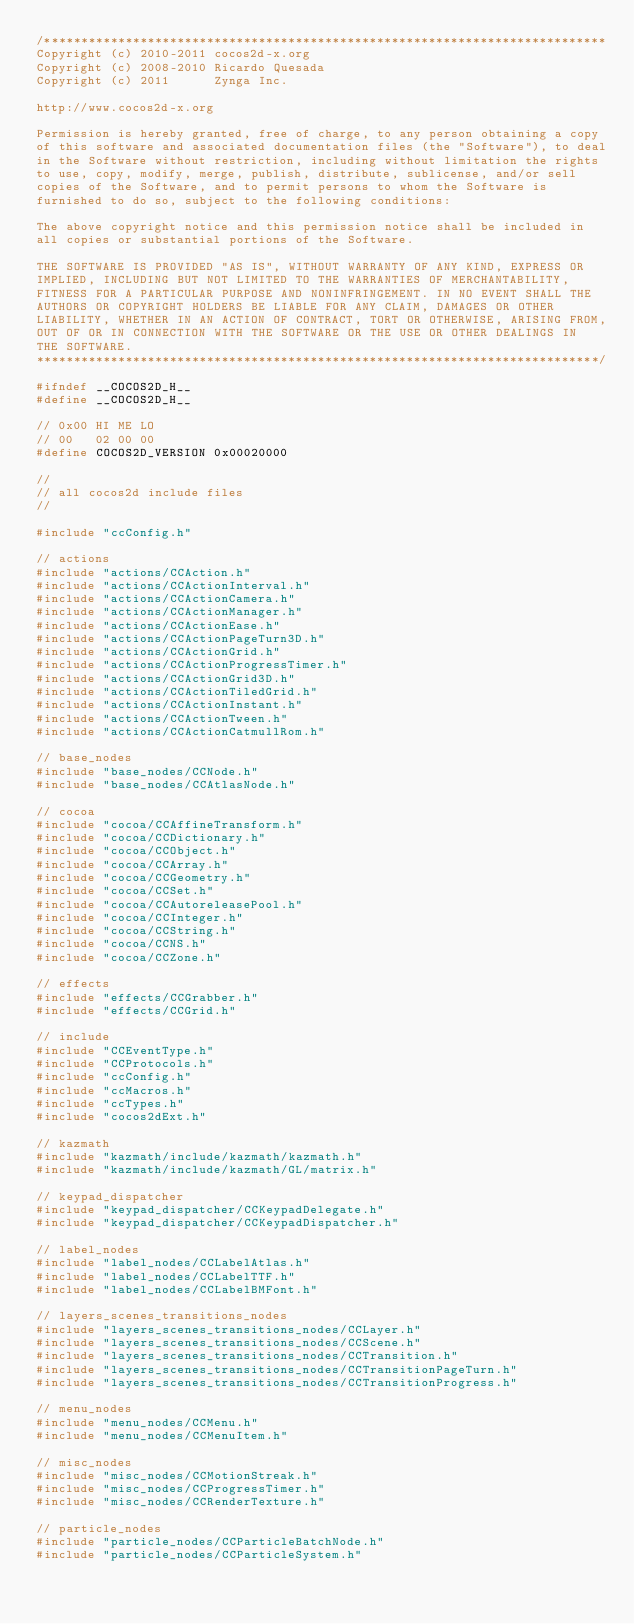<code> <loc_0><loc_0><loc_500><loc_500><_C_>/****************************************************************************
Copyright (c) 2010-2011 cocos2d-x.org
Copyright (c) 2008-2010 Ricardo Quesada
Copyright (c) 2011      Zynga Inc.

http://www.cocos2d-x.org

Permission is hereby granted, free of charge, to any person obtaining a copy
of this software and associated documentation files (the "Software"), to deal
in the Software without restriction, including without limitation the rights
to use, copy, modify, merge, publish, distribute, sublicense, and/or sell
copies of the Software, and to permit persons to whom the Software is
furnished to do so, subject to the following conditions:

The above copyright notice and this permission notice shall be included in
all copies or substantial portions of the Software.

THE SOFTWARE IS PROVIDED "AS IS", WITHOUT WARRANTY OF ANY KIND, EXPRESS OR
IMPLIED, INCLUDING BUT NOT LIMITED TO THE WARRANTIES OF MERCHANTABILITY,
FITNESS FOR A PARTICULAR PURPOSE AND NONINFRINGEMENT. IN NO EVENT SHALL THE
AUTHORS OR COPYRIGHT HOLDERS BE LIABLE FOR ANY CLAIM, DAMAGES OR OTHER
LIABILITY, WHETHER IN AN ACTION OF CONTRACT, TORT OR OTHERWISE, ARISING FROM,
OUT OF OR IN CONNECTION WITH THE SOFTWARE OR THE USE OR OTHER DEALINGS IN
THE SOFTWARE.
****************************************************************************/

#ifndef __COCOS2D_H__
#define __COCOS2D_H__

// 0x00 HI ME LO
// 00   02 00 00
#define COCOS2D_VERSION 0x00020000

//
// all cocos2d include files
//

#include "ccConfig.h"

// actions
#include "actions/CCAction.h"
#include "actions/CCActionInterval.h"
#include "actions/CCActionCamera.h"
#include "actions/CCActionManager.h"
#include "actions/CCActionEase.h"
#include "actions/CCActionPageTurn3D.h"
#include "actions/CCActionGrid.h"
#include "actions/CCActionProgressTimer.h"
#include "actions/CCActionGrid3D.h"
#include "actions/CCActionTiledGrid.h"
#include "actions/CCActionInstant.h"
#include "actions/CCActionTween.h"
#include "actions/CCActionCatmullRom.h"

// base_nodes
#include "base_nodes/CCNode.h"
#include "base_nodes/CCAtlasNode.h"

// cocoa
#include "cocoa/CCAffineTransform.h"
#include "cocoa/CCDictionary.h"
#include "cocoa/CCObject.h"
#include "cocoa/CCArray.h"
#include "cocoa/CCGeometry.h"
#include "cocoa/CCSet.h"
#include "cocoa/CCAutoreleasePool.h"
#include "cocoa/CCInteger.h"
#include "cocoa/CCString.h"
#include "cocoa/CCNS.h"
#include "cocoa/CCZone.h"

// effects
#include "effects/CCGrabber.h"
#include "effects/CCGrid.h"

// include
#include "CCEventType.h"
#include "CCProtocols.h"
#include "ccConfig.h"
#include "ccMacros.h"
#include "ccTypes.h"
#include "cocos2dExt.h"

// kazmath
#include "kazmath/include/kazmath/kazmath.h"
#include "kazmath/include/kazmath/GL/matrix.h"

// keypad_dispatcher
#include "keypad_dispatcher/CCKeypadDelegate.h"
#include "keypad_dispatcher/CCKeypadDispatcher.h"

// label_nodes
#include "label_nodes/CCLabelAtlas.h"
#include "label_nodes/CCLabelTTF.h"
#include "label_nodes/CCLabelBMFont.h"

// layers_scenes_transitions_nodes
#include "layers_scenes_transitions_nodes/CCLayer.h"
#include "layers_scenes_transitions_nodes/CCScene.h"
#include "layers_scenes_transitions_nodes/CCTransition.h"
#include "layers_scenes_transitions_nodes/CCTransitionPageTurn.h"
#include "layers_scenes_transitions_nodes/CCTransitionProgress.h"

// menu_nodes
#include "menu_nodes/CCMenu.h"
#include "menu_nodes/CCMenuItem.h"

// misc_nodes
#include "misc_nodes/CCMotionStreak.h"
#include "misc_nodes/CCProgressTimer.h"
#include "misc_nodes/CCRenderTexture.h"

// particle_nodes
#include "particle_nodes/CCParticleBatchNode.h"
#include "particle_nodes/CCParticleSystem.h"</code> 